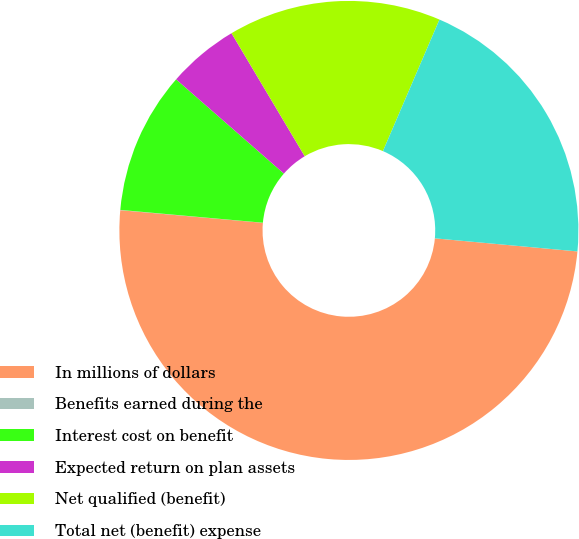Convert chart to OTSL. <chart><loc_0><loc_0><loc_500><loc_500><pie_chart><fcel>In millions of dollars<fcel>Benefits earned during the<fcel>Interest cost on benefit<fcel>Expected return on plan assets<fcel>Net qualified (benefit)<fcel>Total net (benefit) expense<nl><fcel>49.95%<fcel>0.02%<fcel>10.01%<fcel>5.02%<fcel>15.0%<fcel>20.0%<nl></chart> 